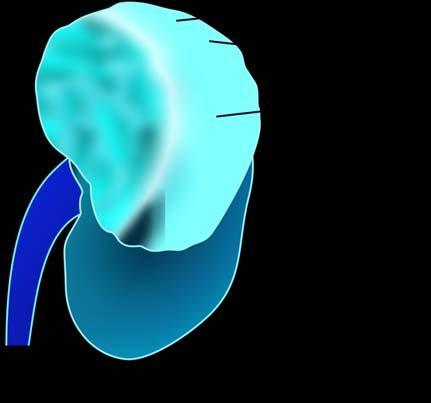does the upper pole of the kidney show a large and tan mass while rest of the kidney has reniform contour?
Answer the question using a single word or phrase. Yes 